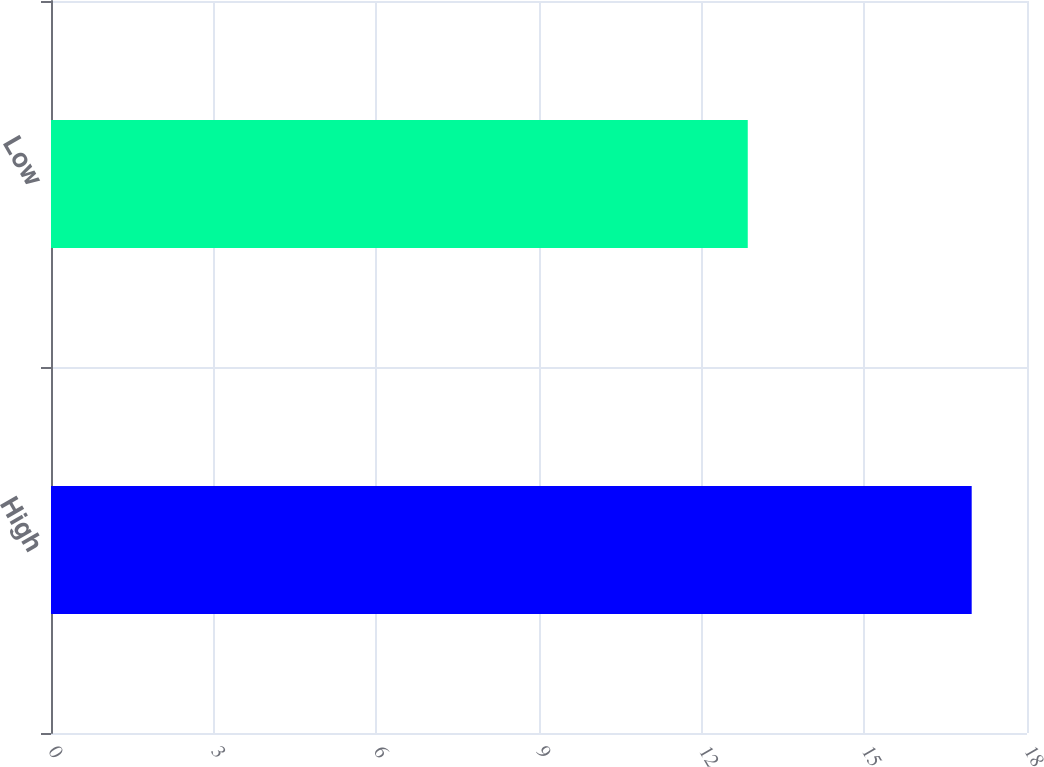Convert chart. <chart><loc_0><loc_0><loc_500><loc_500><bar_chart><fcel>High<fcel>Low<nl><fcel>16.98<fcel>12.85<nl></chart> 